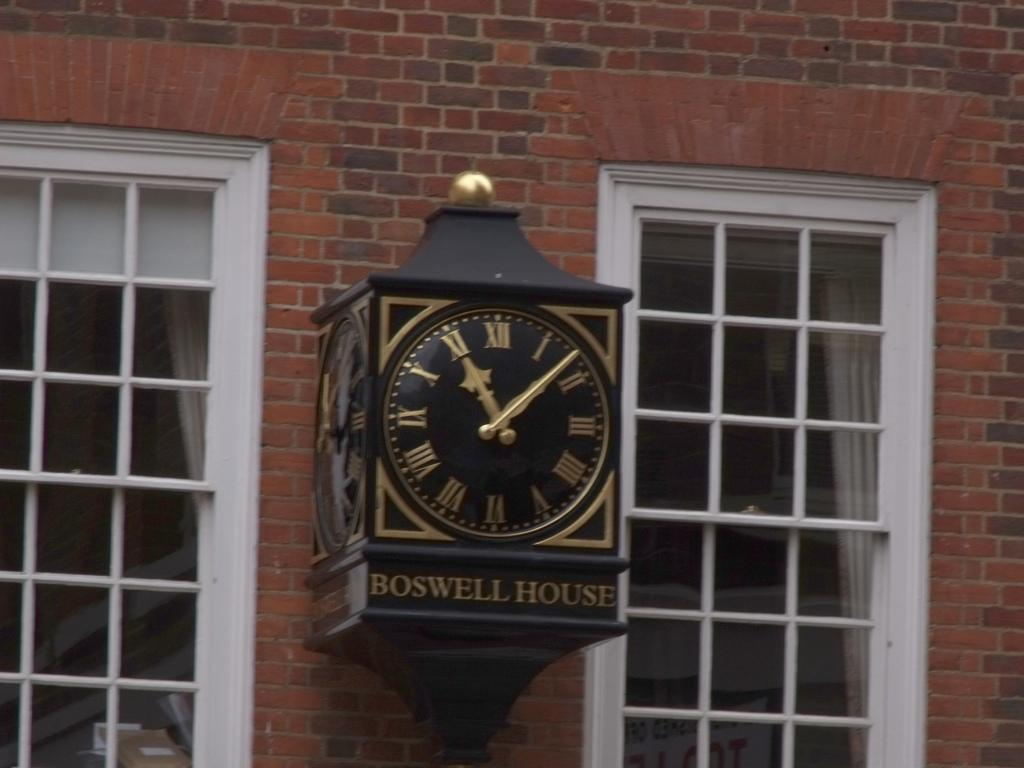<image>
Describe the image concisely. An antique looking gold and black clock with the name Boswell House on the bottom is hanging on the outside of a brick wall, between two windows. 